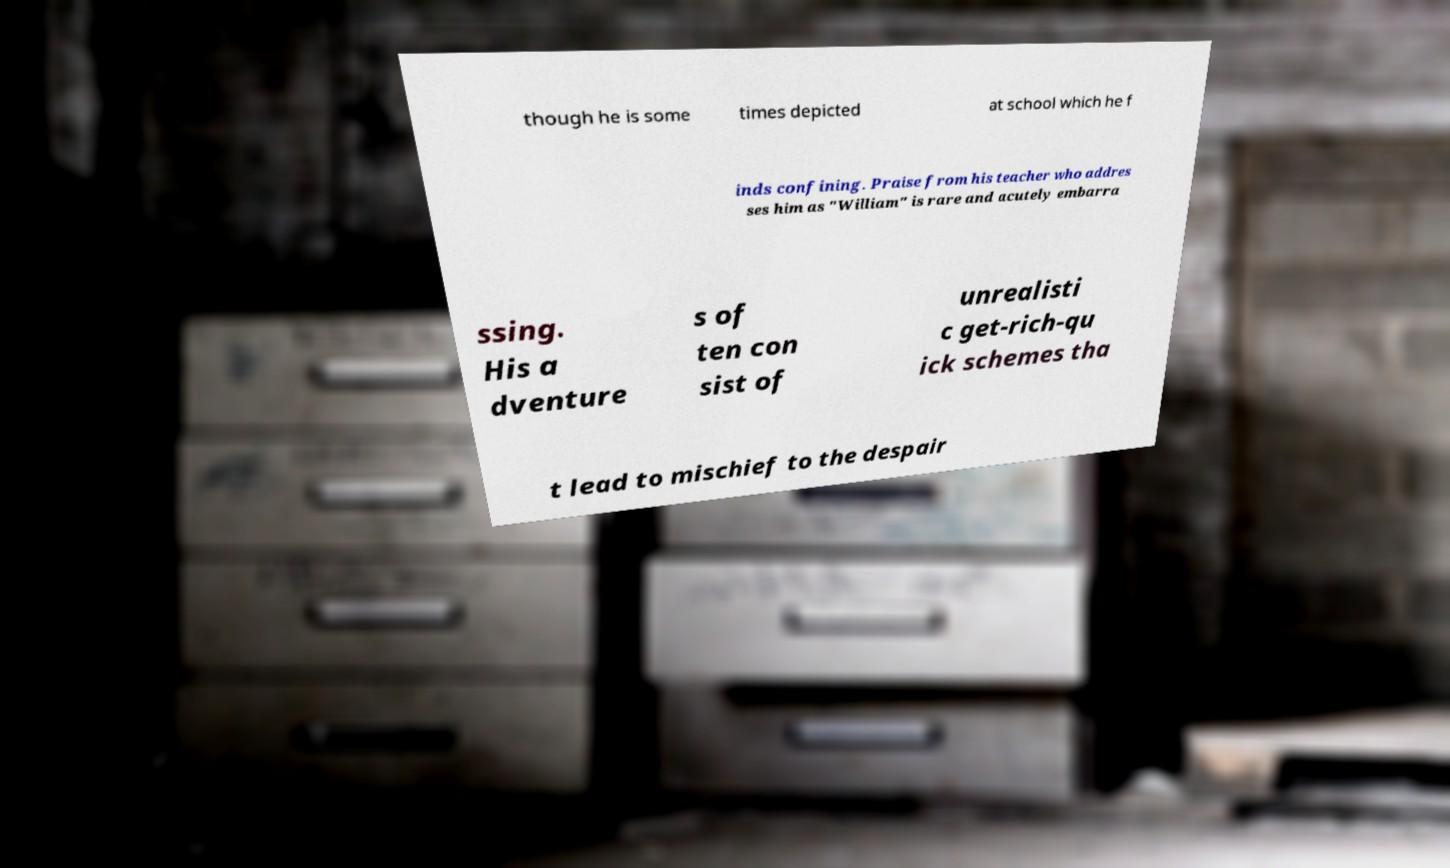What messages or text are displayed in this image? I need them in a readable, typed format. though he is some times depicted at school which he f inds confining. Praise from his teacher who addres ses him as "William" is rare and acutely embarra ssing. His a dventure s of ten con sist of unrealisti c get-rich-qu ick schemes tha t lead to mischief to the despair 